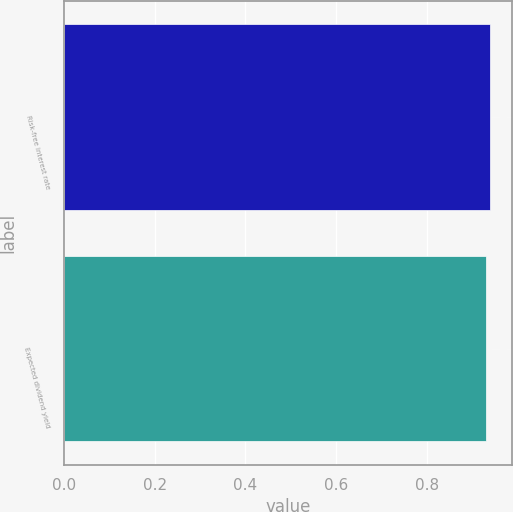Convert chart. <chart><loc_0><loc_0><loc_500><loc_500><bar_chart><fcel>Risk-free interest rate<fcel>Expected dividend yield<nl><fcel>0.94<fcel>0.93<nl></chart> 